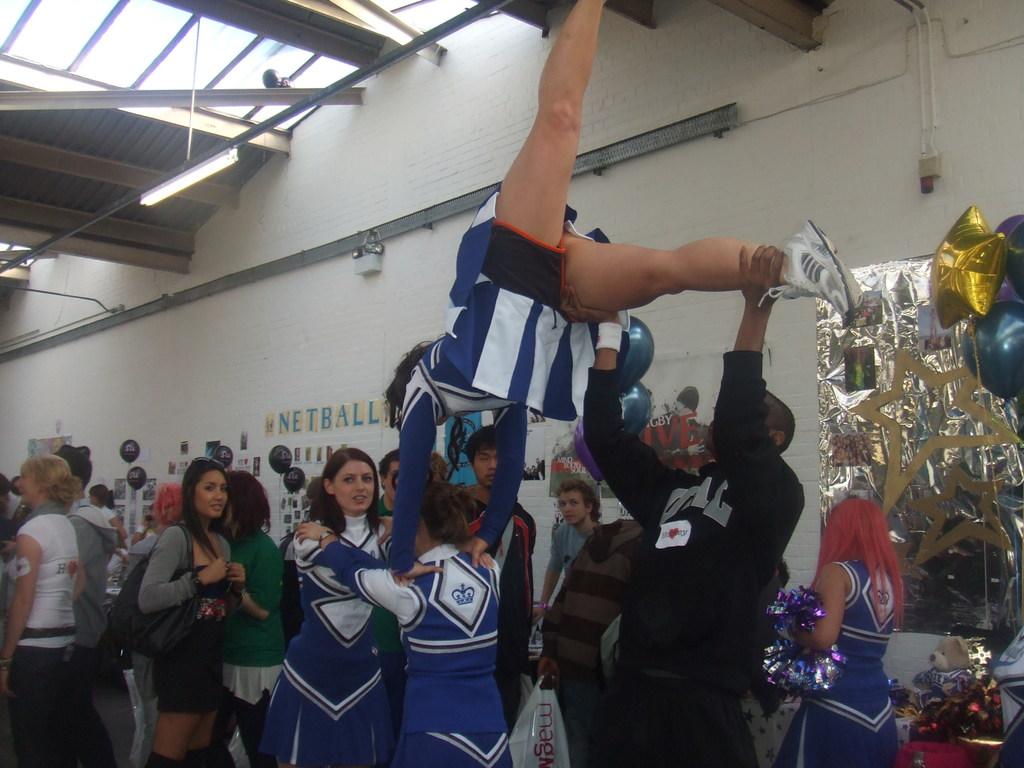Are they practing gymnastics?
Your answer should be very brief. Answering does not require reading text in the image. What is written in blue on the wall?
Make the answer very short. Netball. 